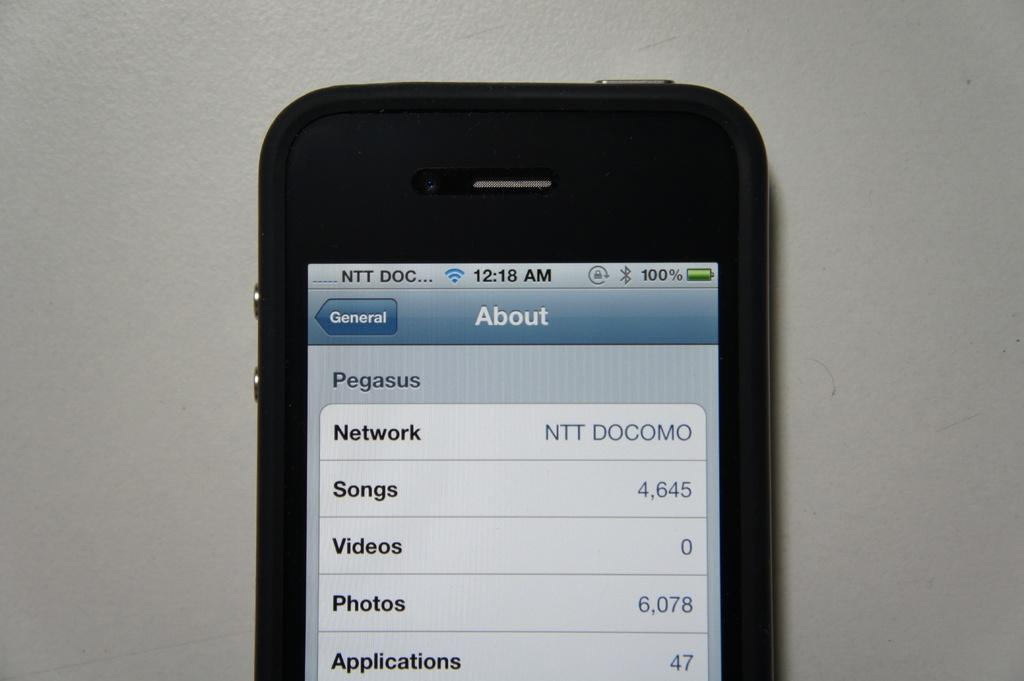<image>
Describe the image concisely. The phone has exactly 4645 different songs on it 